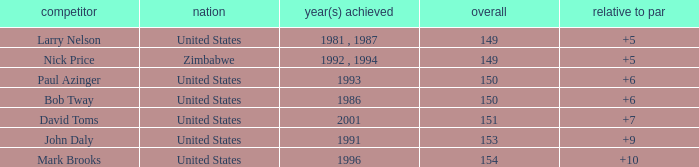What is Zimbabwe's total with a to par higher than 5? None. 